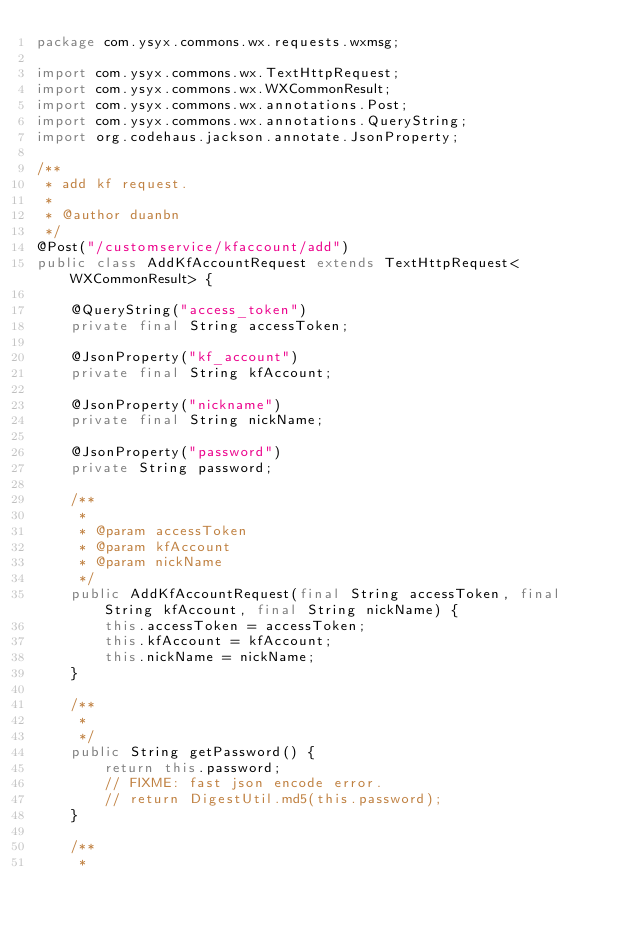Convert code to text. <code><loc_0><loc_0><loc_500><loc_500><_Java_>package com.ysyx.commons.wx.requests.wxmsg;

import com.ysyx.commons.wx.TextHttpRequest;
import com.ysyx.commons.wx.WXCommonResult;
import com.ysyx.commons.wx.annotations.Post;
import com.ysyx.commons.wx.annotations.QueryString;
import org.codehaus.jackson.annotate.JsonProperty;

/**
 * add kf request.
 *
 * @author duanbn
 */
@Post("/customservice/kfaccount/add")
public class AddKfAccountRequest extends TextHttpRequest<WXCommonResult> {

	@QueryString("access_token")
	private final String accessToken;

	@JsonProperty("kf_account")
	private final String kfAccount;

	@JsonProperty("nickname")
	private final String nickName;

	@JsonProperty("password")
	private String password;

	/**
	 * 
	 * @param accessToken
	 * @param kfAccount
	 * @param nickName
	 */
	public AddKfAccountRequest(final String accessToken, final String kfAccount, final String nickName) {
		this.accessToken = accessToken;
		this.kfAccount = kfAccount;
		this.nickName = nickName;
	}

	/**
     *
     */
	public String getPassword() {
		return this.password;
		// FIXME: fast json encode error.
		// return DigestUtil.md5(this.password);
	}

	/**
     *</code> 